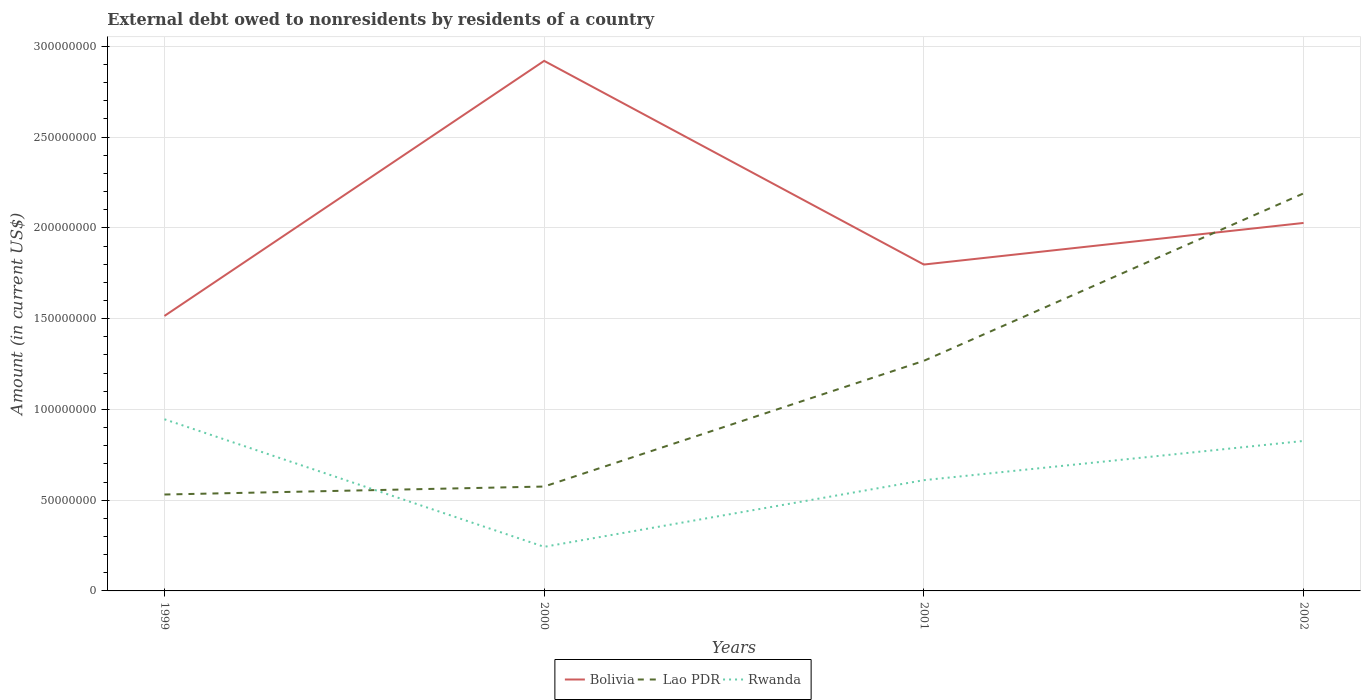How many different coloured lines are there?
Offer a terse response. 3. Across all years, what is the maximum external debt owed by residents in Lao PDR?
Ensure brevity in your answer.  5.31e+07. What is the total external debt owed by residents in Lao PDR in the graph?
Keep it short and to the point. -9.22e+07. What is the difference between the highest and the second highest external debt owed by residents in Bolivia?
Your answer should be compact. 1.41e+08. What is the difference between the highest and the lowest external debt owed by residents in Bolivia?
Your answer should be very brief. 1. Is the external debt owed by residents in Rwanda strictly greater than the external debt owed by residents in Bolivia over the years?
Your answer should be very brief. Yes. How many lines are there?
Provide a short and direct response. 3. How many years are there in the graph?
Your answer should be compact. 4. Does the graph contain any zero values?
Your answer should be compact. No. How many legend labels are there?
Make the answer very short. 3. How are the legend labels stacked?
Your answer should be compact. Horizontal. What is the title of the graph?
Provide a succinct answer. External debt owed to nonresidents by residents of a country. What is the label or title of the X-axis?
Your answer should be compact. Years. What is the label or title of the Y-axis?
Ensure brevity in your answer.  Amount (in current US$). What is the Amount (in current US$) in Bolivia in 1999?
Offer a terse response. 1.51e+08. What is the Amount (in current US$) in Lao PDR in 1999?
Ensure brevity in your answer.  5.31e+07. What is the Amount (in current US$) of Rwanda in 1999?
Your response must be concise. 9.46e+07. What is the Amount (in current US$) in Bolivia in 2000?
Make the answer very short. 2.92e+08. What is the Amount (in current US$) of Lao PDR in 2000?
Provide a succinct answer. 5.75e+07. What is the Amount (in current US$) in Rwanda in 2000?
Offer a terse response. 2.43e+07. What is the Amount (in current US$) in Bolivia in 2001?
Your answer should be compact. 1.80e+08. What is the Amount (in current US$) of Lao PDR in 2001?
Provide a succinct answer. 1.27e+08. What is the Amount (in current US$) of Rwanda in 2001?
Your answer should be very brief. 6.10e+07. What is the Amount (in current US$) of Bolivia in 2002?
Offer a terse response. 2.03e+08. What is the Amount (in current US$) in Lao PDR in 2002?
Your answer should be very brief. 2.19e+08. What is the Amount (in current US$) of Rwanda in 2002?
Offer a terse response. 8.26e+07. Across all years, what is the maximum Amount (in current US$) of Bolivia?
Keep it short and to the point. 2.92e+08. Across all years, what is the maximum Amount (in current US$) of Lao PDR?
Keep it short and to the point. 2.19e+08. Across all years, what is the maximum Amount (in current US$) of Rwanda?
Offer a terse response. 9.46e+07. Across all years, what is the minimum Amount (in current US$) in Bolivia?
Make the answer very short. 1.51e+08. Across all years, what is the minimum Amount (in current US$) of Lao PDR?
Offer a terse response. 5.31e+07. Across all years, what is the minimum Amount (in current US$) in Rwanda?
Your response must be concise. 2.43e+07. What is the total Amount (in current US$) of Bolivia in the graph?
Offer a very short reply. 8.26e+08. What is the total Amount (in current US$) in Lao PDR in the graph?
Provide a succinct answer. 4.56e+08. What is the total Amount (in current US$) of Rwanda in the graph?
Offer a terse response. 2.62e+08. What is the difference between the Amount (in current US$) in Bolivia in 1999 and that in 2000?
Your answer should be compact. -1.41e+08. What is the difference between the Amount (in current US$) in Lao PDR in 1999 and that in 2000?
Your answer should be very brief. -4.39e+06. What is the difference between the Amount (in current US$) of Rwanda in 1999 and that in 2000?
Make the answer very short. 7.03e+07. What is the difference between the Amount (in current US$) of Bolivia in 1999 and that in 2001?
Ensure brevity in your answer.  -2.83e+07. What is the difference between the Amount (in current US$) in Lao PDR in 1999 and that in 2001?
Keep it short and to the point. -7.37e+07. What is the difference between the Amount (in current US$) in Rwanda in 1999 and that in 2001?
Keep it short and to the point. 3.36e+07. What is the difference between the Amount (in current US$) of Bolivia in 1999 and that in 2002?
Make the answer very short. -5.12e+07. What is the difference between the Amount (in current US$) of Lao PDR in 1999 and that in 2002?
Offer a terse response. -1.66e+08. What is the difference between the Amount (in current US$) of Rwanda in 1999 and that in 2002?
Make the answer very short. 1.19e+07. What is the difference between the Amount (in current US$) of Bolivia in 2000 and that in 2001?
Offer a terse response. 1.12e+08. What is the difference between the Amount (in current US$) in Lao PDR in 2000 and that in 2001?
Offer a very short reply. -6.93e+07. What is the difference between the Amount (in current US$) in Rwanda in 2000 and that in 2001?
Your answer should be very brief. -3.67e+07. What is the difference between the Amount (in current US$) of Bolivia in 2000 and that in 2002?
Ensure brevity in your answer.  8.93e+07. What is the difference between the Amount (in current US$) in Lao PDR in 2000 and that in 2002?
Provide a short and direct response. -1.62e+08. What is the difference between the Amount (in current US$) of Rwanda in 2000 and that in 2002?
Give a very brief answer. -5.83e+07. What is the difference between the Amount (in current US$) of Bolivia in 2001 and that in 2002?
Give a very brief answer. -2.29e+07. What is the difference between the Amount (in current US$) of Lao PDR in 2001 and that in 2002?
Ensure brevity in your answer.  -9.22e+07. What is the difference between the Amount (in current US$) of Rwanda in 2001 and that in 2002?
Ensure brevity in your answer.  -2.16e+07. What is the difference between the Amount (in current US$) of Bolivia in 1999 and the Amount (in current US$) of Lao PDR in 2000?
Provide a short and direct response. 9.40e+07. What is the difference between the Amount (in current US$) in Bolivia in 1999 and the Amount (in current US$) in Rwanda in 2000?
Make the answer very short. 1.27e+08. What is the difference between the Amount (in current US$) in Lao PDR in 1999 and the Amount (in current US$) in Rwanda in 2000?
Your answer should be compact. 2.88e+07. What is the difference between the Amount (in current US$) in Bolivia in 1999 and the Amount (in current US$) in Lao PDR in 2001?
Offer a terse response. 2.47e+07. What is the difference between the Amount (in current US$) of Bolivia in 1999 and the Amount (in current US$) of Rwanda in 2001?
Offer a very short reply. 9.05e+07. What is the difference between the Amount (in current US$) of Lao PDR in 1999 and the Amount (in current US$) of Rwanda in 2001?
Provide a short and direct response. -7.90e+06. What is the difference between the Amount (in current US$) in Bolivia in 1999 and the Amount (in current US$) in Lao PDR in 2002?
Provide a succinct answer. -6.75e+07. What is the difference between the Amount (in current US$) of Bolivia in 1999 and the Amount (in current US$) of Rwanda in 2002?
Ensure brevity in your answer.  6.89e+07. What is the difference between the Amount (in current US$) in Lao PDR in 1999 and the Amount (in current US$) in Rwanda in 2002?
Your response must be concise. -2.95e+07. What is the difference between the Amount (in current US$) of Bolivia in 2000 and the Amount (in current US$) of Lao PDR in 2001?
Provide a short and direct response. 1.65e+08. What is the difference between the Amount (in current US$) in Bolivia in 2000 and the Amount (in current US$) in Rwanda in 2001?
Offer a very short reply. 2.31e+08. What is the difference between the Amount (in current US$) of Lao PDR in 2000 and the Amount (in current US$) of Rwanda in 2001?
Offer a very short reply. -3.51e+06. What is the difference between the Amount (in current US$) of Bolivia in 2000 and the Amount (in current US$) of Lao PDR in 2002?
Your answer should be very brief. 7.30e+07. What is the difference between the Amount (in current US$) in Bolivia in 2000 and the Amount (in current US$) in Rwanda in 2002?
Provide a short and direct response. 2.09e+08. What is the difference between the Amount (in current US$) of Lao PDR in 2000 and the Amount (in current US$) of Rwanda in 2002?
Your response must be concise. -2.51e+07. What is the difference between the Amount (in current US$) of Bolivia in 2001 and the Amount (in current US$) of Lao PDR in 2002?
Your response must be concise. -3.92e+07. What is the difference between the Amount (in current US$) in Bolivia in 2001 and the Amount (in current US$) in Rwanda in 2002?
Your answer should be compact. 9.72e+07. What is the difference between the Amount (in current US$) in Lao PDR in 2001 and the Amount (in current US$) in Rwanda in 2002?
Ensure brevity in your answer.  4.41e+07. What is the average Amount (in current US$) in Bolivia per year?
Your answer should be very brief. 2.07e+08. What is the average Amount (in current US$) of Lao PDR per year?
Give a very brief answer. 1.14e+08. What is the average Amount (in current US$) of Rwanda per year?
Give a very brief answer. 6.56e+07. In the year 1999, what is the difference between the Amount (in current US$) in Bolivia and Amount (in current US$) in Lao PDR?
Keep it short and to the point. 9.84e+07. In the year 1999, what is the difference between the Amount (in current US$) of Bolivia and Amount (in current US$) of Rwanda?
Offer a very short reply. 5.69e+07. In the year 1999, what is the difference between the Amount (in current US$) in Lao PDR and Amount (in current US$) in Rwanda?
Provide a succinct answer. -4.15e+07. In the year 2000, what is the difference between the Amount (in current US$) of Bolivia and Amount (in current US$) of Lao PDR?
Your answer should be very brief. 2.35e+08. In the year 2000, what is the difference between the Amount (in current US$) of Bolivia and Amount (in current US$) of Rwanda?
Your response must be concise. 2.68e+08. In the year 2000, what is the difference between the Amount (in current US$) of Lao PDR and Amount (in current US$) of Rwanda?
Offer a very short reply. 3.32e+07. In the year 2001, what is the difference between the Amount (in current US$) of Bolivia and Amount (in current US$) of Lao PDR?
Ensure brevity in your answer.  5.30e+07. In the year 2001, what is the difference between the Amount (in current US$) of Bolivia and Amount (in current US$) of Rwanda?
Offer a very short reply. 1.19e+08. In the year 2001, what is the difference between the Amount (in current US$) of Lao PDR and Amount (in current US$) of Rwanda?
Provide a short and direct response. 6.58e+07. In the year 2002, what is the difference between the Amount (in current US$) in Bolivia and Amount (in current US$) in Lao PDR?
Your answer should be compact. -1.63e+07. In the year 2002, what is the difference between the Amount (in current US$) of Bolivia and Amount (in current US$) of Rwanda?
Provide a short and direct response. 1.20e+08. In the year 2002, what is the difference between the Amount (in current US$) of Lao PDR and Amount (in current US$) of Rwanda?
Offer a very short reply. 1.36e+08. What is the ratio of the Amount (in current US$) in Bolivia in 1999 to that in 2000?
Make the answer very short. 0.52. What is the ratio of the Amount (in current US$) in Lao PDR in 1999 to that in 2000?
Your answer should be very brief. 0.92. What is the ratio of the Amount (in current US$) of Rwanda in 1999 to that in 2000?
Ensure brevity in your answer.  3.89. What is the ratio of the Amount (in current US$) of Bolivia in 1999 to that in 2001?
Make the answer very short. 0.84. What is the ratio of the Amount (in current US$) of Lao PDR in 1999 to that in 2001?
Your response must be concise. 0.42. What is the ratio of the Amount (in current US$) of Rwanda in 1999 to that in 2001?
Offer a terse response. 1.55. What is the ratio of the Amount (in current US$) of Bolivia in 1999 to that in 2002?
Your response must be concise. 0.75. What is the ratio of the Amount (in current US$) in Lao PDR in 1999 to that in 2002?
Ensure brevity in your answer.  0.24. What is the ratio of the Amount (in current US$) of Rwanda in 1999 to that in 2002?
Provide a succinct answer. 1.14. What is the ratio of the Amount (in current US$) of Bolivia in 2000 to that in 2001?
Give a very brief answer. 1.62. What is the ratio of the Amount (in current US$) of Lao PDR in 2000 to that in 2001?
Your answer should be very brief. 0.45. What is the ratio of the Amount (in current US$) of Rwanda in 2000 to that in 2001?
Your answer should be compact. 0.4. What is the ratio of the Amount (in current US$) of Bolivia in 2000 to that in 2002?
Ensure brevity in your answer.  1.44. What is the ratio of the Amount (in current US$) in Lao PDR in 2000 to that in 2002?
Provide a short and direct response. 0.26. What is the ratio of the Amount (in current US$) of Rwanda in 2000 to that in 2002?
Keep it short and to the point. 0.29. What is the ratio of the Amount (in current US$) in Bolivia in 2001 to that in 2002?
Provide a succinct answer. 0.89. What is the ratio of the Amount (in current US$) in Lao PDR in 2001 to that in 2002?
Make the answer very short. 0.58. What is the ratio of the Amount (in current US$) of Rwanda in 2001 to that in 2002?
Your answer should be compact. 0.74. What is the difference between the highest and the second highest Amount (in current US$) of Bolivia?
Give a very brief answer. 8.93e+07. What is the difference between the highest and the second highest Amount (in current US$) of Lao PDR?
Make the answer very short. 9.22e+07. What is the difference between the highest and the second highest Amount (in current US$) of Rwanda?
Your response must be concise. 1.19e+07. What is the difference between the highest and the lowest Amount (in current US$) in Bolivia?
Make the answer very short. 1.41e+08. What is the difference between the highest and the lowest Amount (in current US$) of Lao PDR?
Your answer should be compact. 1.66e+08. What is the difference between the highest and the lowest Amount (in current US$) in Rwanda?
Offer a terse response. 7.03e+07. 